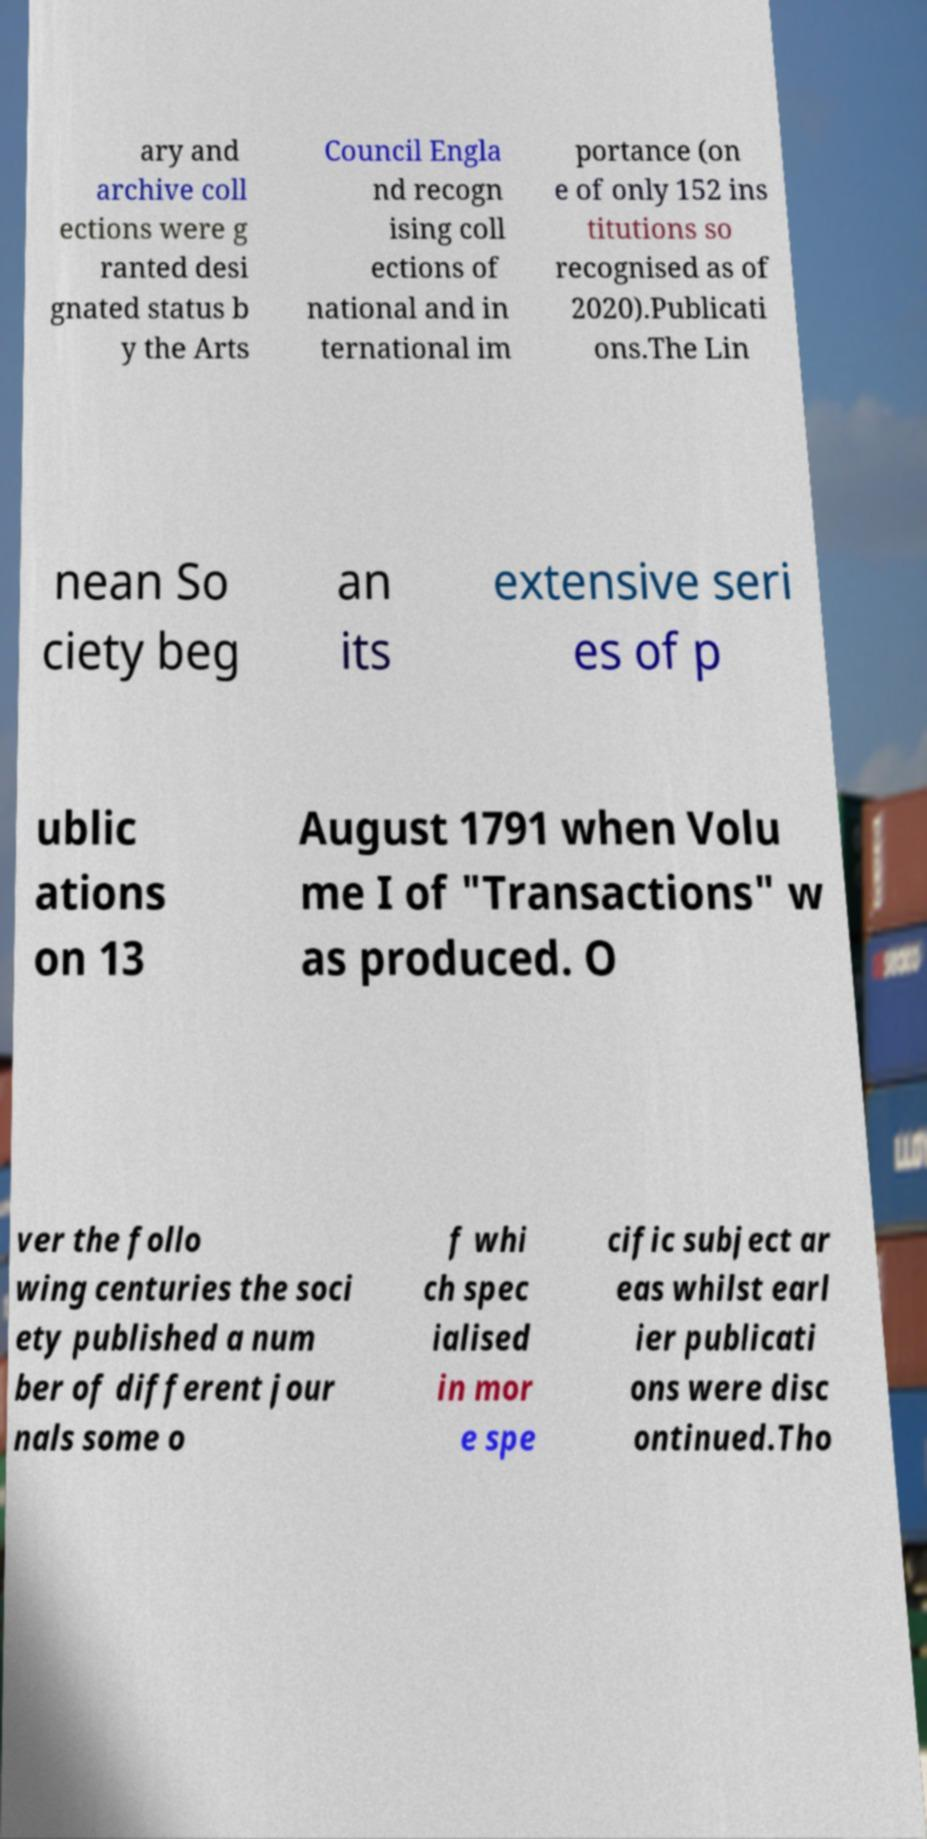Could you assist in decoding the text presented in this image and type it out clearly? ary and archive coll ections were g ranted desi gnated status b y the Arts Council Engla nd recogn ising coll ections of national and in ternational im portance (on e of only 152 ins titutions so recognised as of 2020).Publicati ons.The Lin nean So ciety beg an its extensive seri es of p ublic ations on 13 August 1791 when Volu me I of "Transactions" w as produced. O ver the follo wing centuries the soci ety published a num ber of different jour nals some o f whi ch spec ialised in mor e spe cific subject ar eas whilst earl ier publicati ons were disc ontinued.Tho 